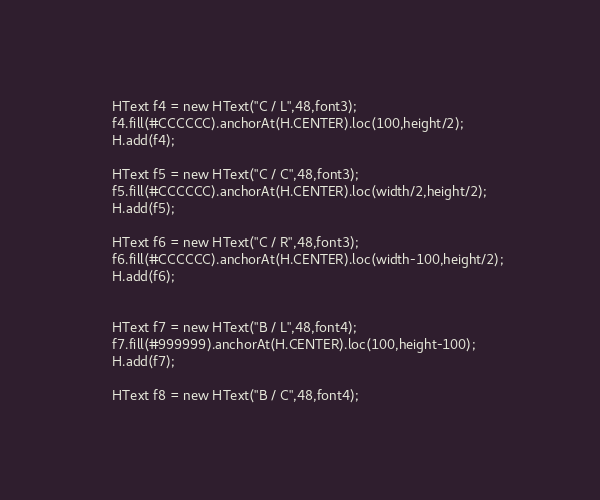Convert code to text. <code><loc_0><loc_0><loc_500><loc_500><_HTML_>

	HText f4 = new HText("C / L",48,font3);
	f4.fill(#CCCCCC).anchorAt(H.CENTER).loc(100,height/2);
	H.add(f4);

	HText f5 = new HText("C / C",48,font3);
	f5.fill(#CCCCCC).anchorAt(H.CENTER).loc(width/2,height/2);
	H.add(f5);

	HText f6 = new HText("C / R",48,font3);
	f6.fill(#CCCCCC).anchorAt(H.CENTER).loc(width-100,height/2);
	H.add(f6);


	HText f7 = new HText("B / L",48,font4);
	f7.fill(#999999).anchorAt(H.CENTER).loc(100,height-100);
	H.add(f7);

	HText f8 = new HText("B / C",48,font4);</code> 